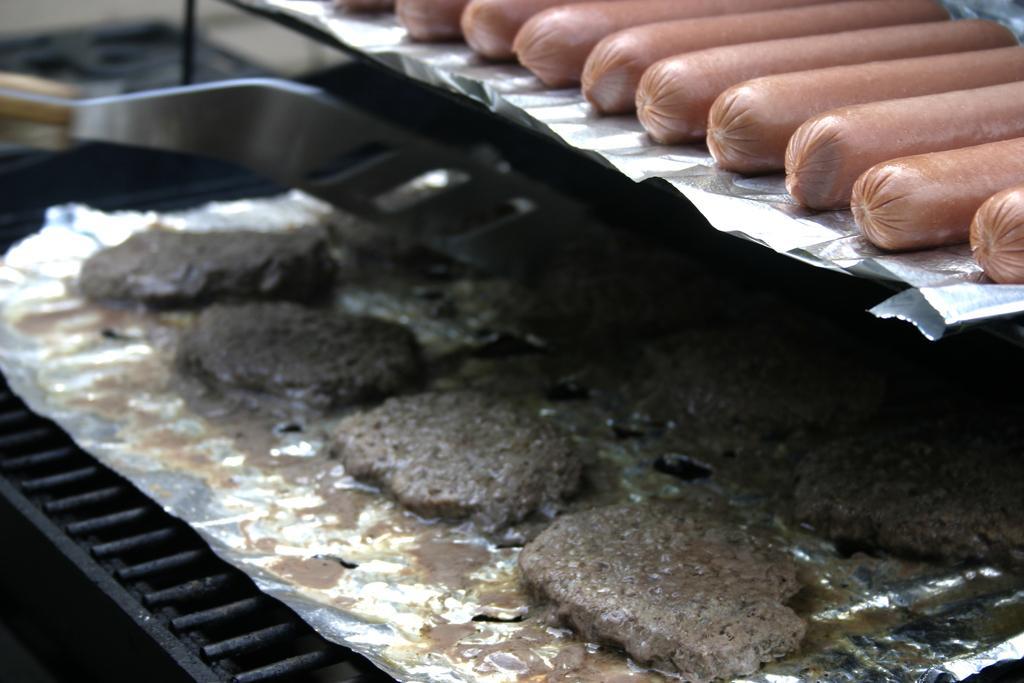Can you describe this image briefly? In this picture I can see sausages on the aluminium foil, there is another food item on the aluminium foil, which is on the grill, and in the background there are some objects. 